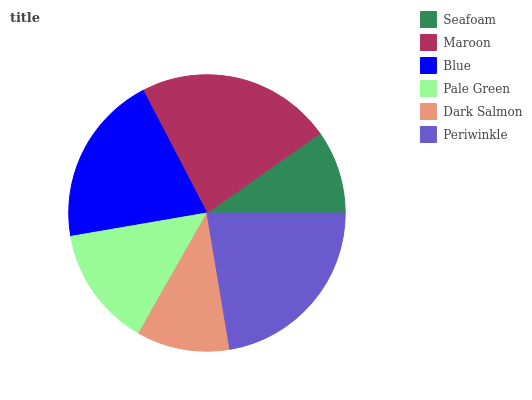Is Seafoam the minimum?
Answer yes or no. Yes. Is Maroon the maximum?
Answer yes or no. Yes. Is Blue the minimum?
Answer yes or no. No. Is Blue the maximum?
Answer yes or no. No. Is Maroon greater than Blue?
Answer yes or no. Yes. Is Blue less than Maroon?
Answer yes or no. Yes. Is Blue greater than Maroon?
Answer yes or no. No. Is Maroon less than Blue?
Answer yes or no. No. Is Blue the high median?
Answer yes or no. Yes. Is Pale Green the low median?
Answer yes or no. Yes. Is Dark Salmon the high median?
Answer yes or no. No. Is Dark Salmon the low median?
Answer yes or no. No. 